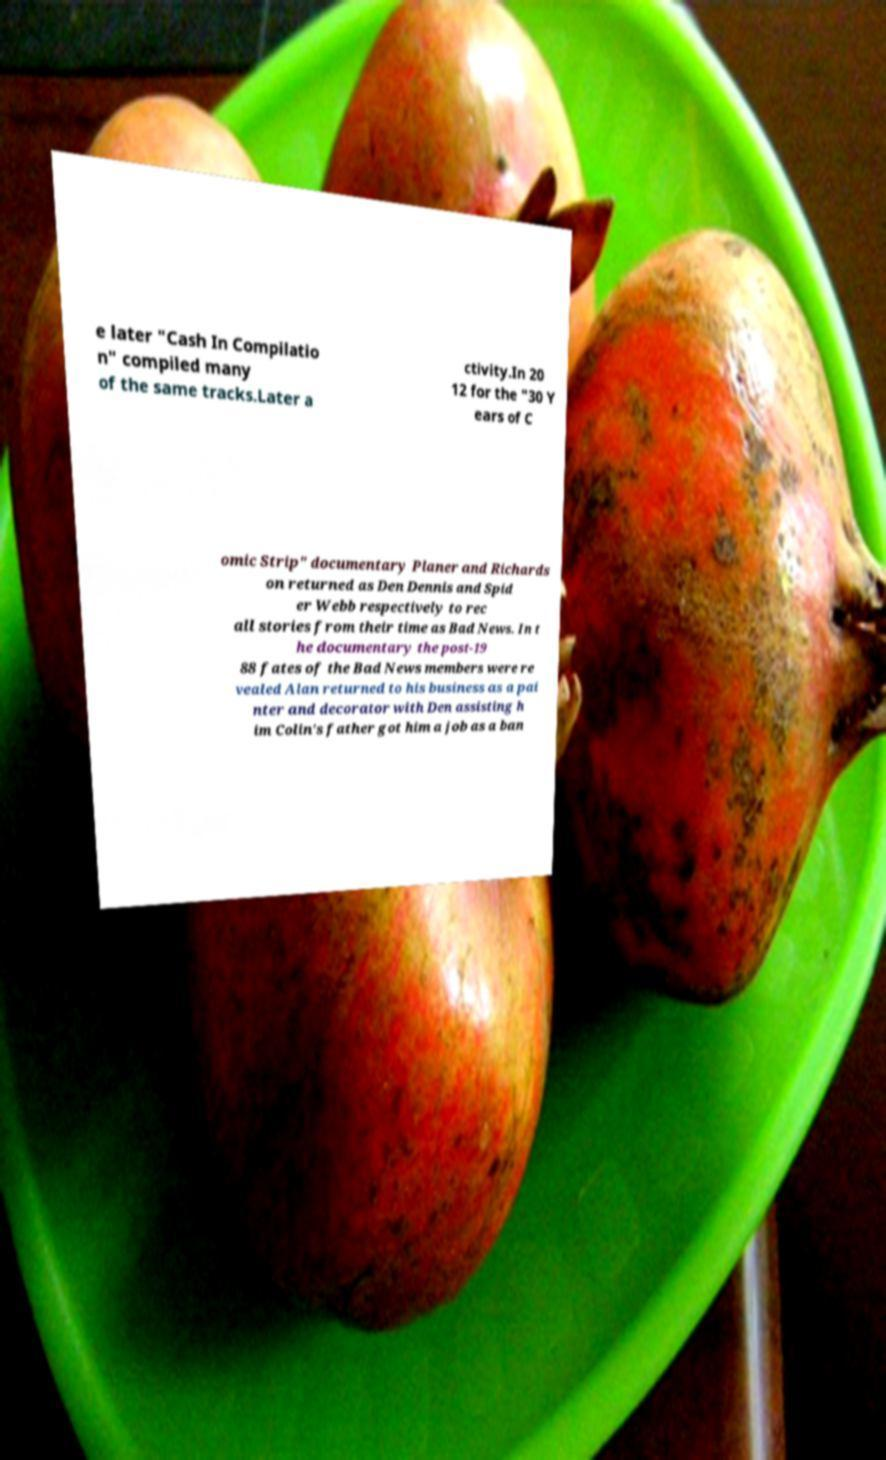There's text embedded in this image that I need extracted. Can you transcribe it verbatim? e later "Cash In Compilatio n" compiled many of the same tracks.Later a ctivity.In 20 12 for the "30 Y ears of C omic Strip" documentary Planer and Richards on returned as Den Dennis and Spid er Webb respectively to rec all stories from their time as Bad News. In t he documentary the post-19 88 fates of the Bad News members were re vealed Alan returned to his business as a pai nter and decorator with Den assisting h im Colin's father got him a job as a ban 